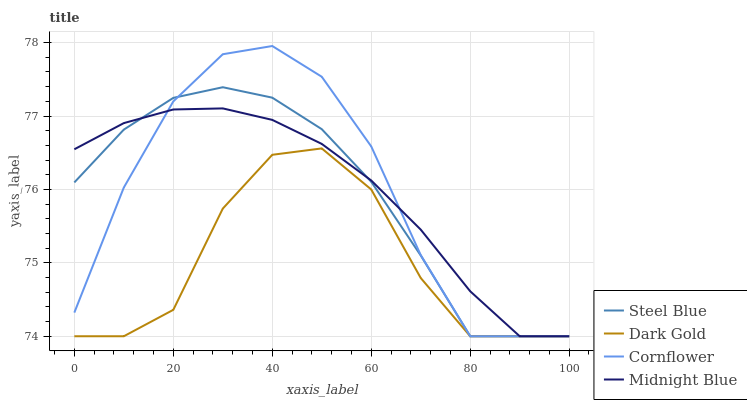Does Dark Gold have the minimum area under the curve?
Answer yes or no. Yes. Does Cornflower have the maximum area under the curve?
Answer yes or no. Yes. Does Midnight Blue have the minimum area under the curve?
Answer yes or no. No. Does Midnight Blue have the maximum area under the curve?
Answer yes or no. No. Is Midnight Blue the smoothest?
Answer yes or no. Yes. Is Dark Gold the roughest?
Answer yes or no. Yes. Is Steel Blue the smoothest?
Answer yes or no. No. Is Steel Blue the roughest?
Answer yes or no. No. Does Cornflower have the lowest value?
Answer yes or no. Yes. Does Cornflower have the highest value?
Answer yes or no. Yes. Does Midnight Blue have the highest value?
Answer yes or no. No. Does Midnight Blue intersect Dark Gold?
Answer yes or no. Yes. Is Midnight Blue less than Dark Gold?
Answer yes or no. No. Is Midnight Blue greater than Dark Gold?
Answer yes or no. No. 